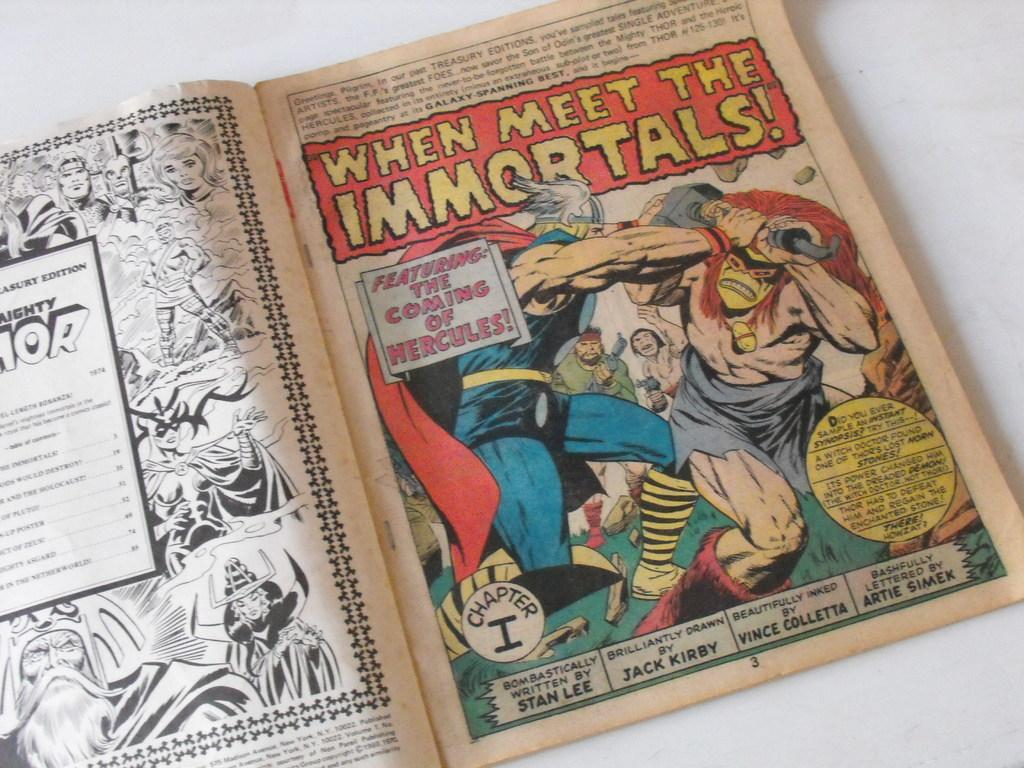Provide a one-sentence caption for the provided image. A comic book is opened at the title page of a strip called When Meet The Immortals. 